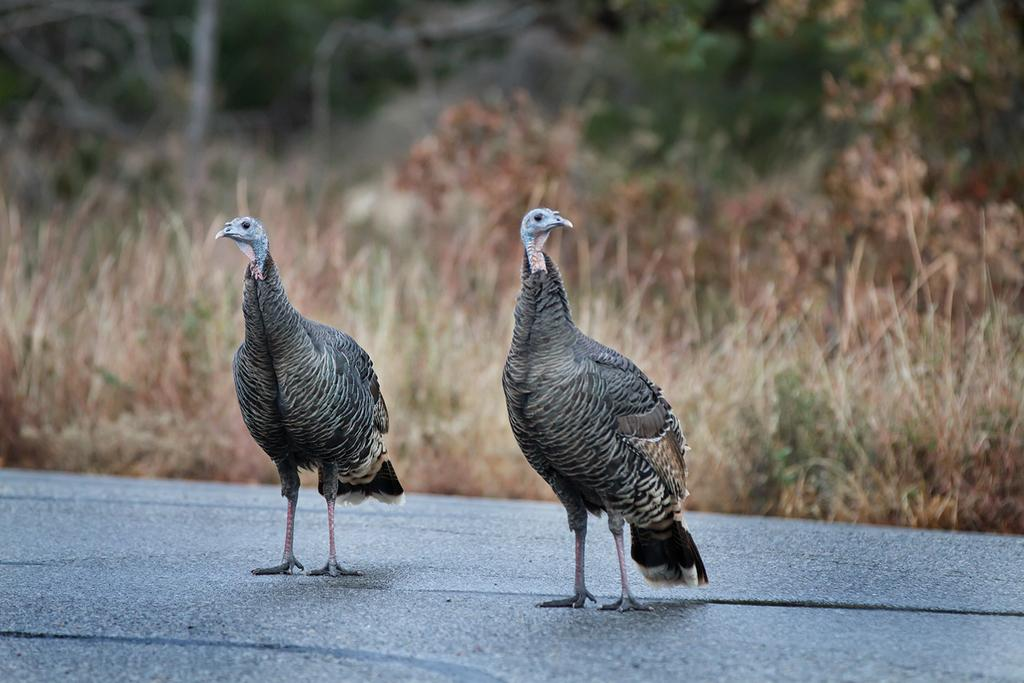What is the main subject of the image? The main subject of the image is birds. Where are the birds located in the image? The birds are in the center of the image. What can be seen in the background of the image? There are trees in the background of the image. What is the interest rate on the loan mentioned in the image? There is no mention of a loan or interest rate in the image; it features birds and trees. 